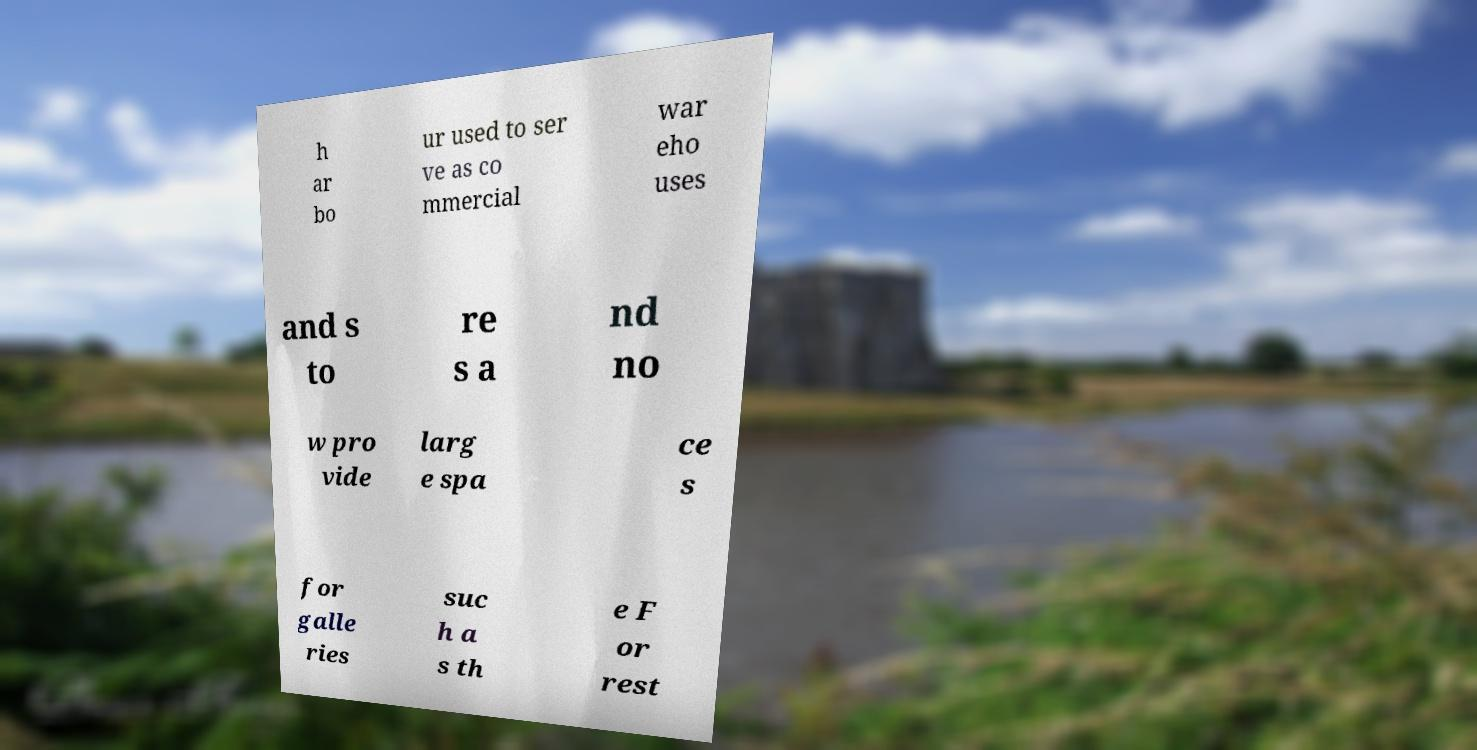I need the written content from this picture converted into text. Can you do that? h ar bo ur used to ser ve as co mmercial war eho uses and s to re s a nd no w pro vide larg e spa ce s for galle ries suc h a s th e F or rest 